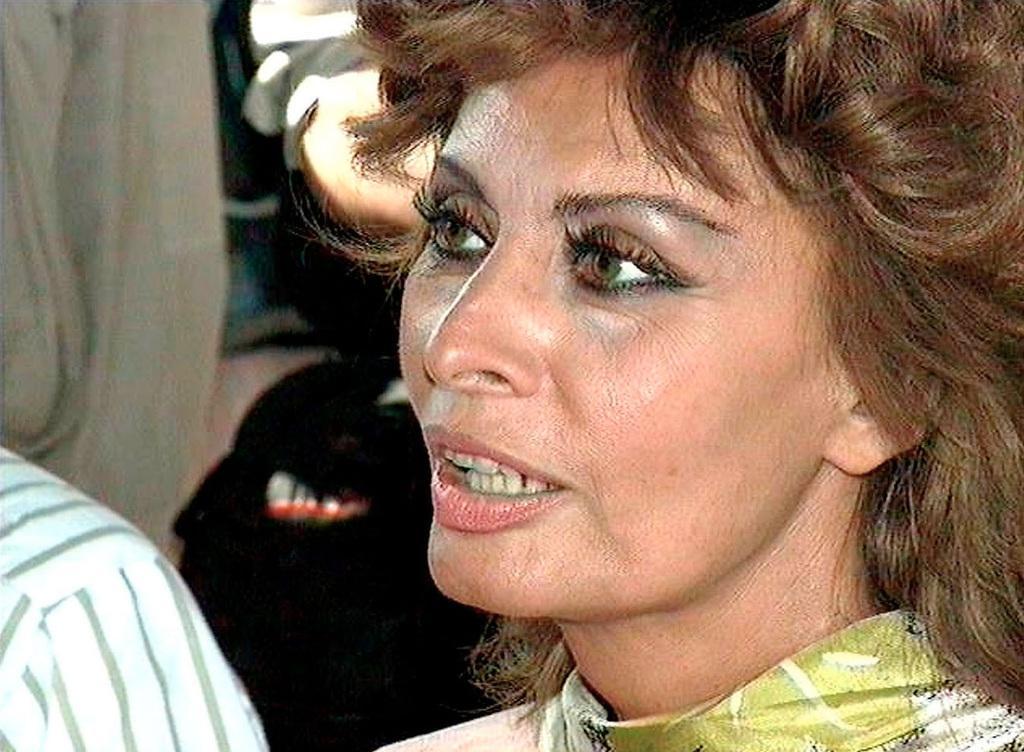Please provide a concise description of this image. In the picture there is a woman, beside the woman there may be people present. 